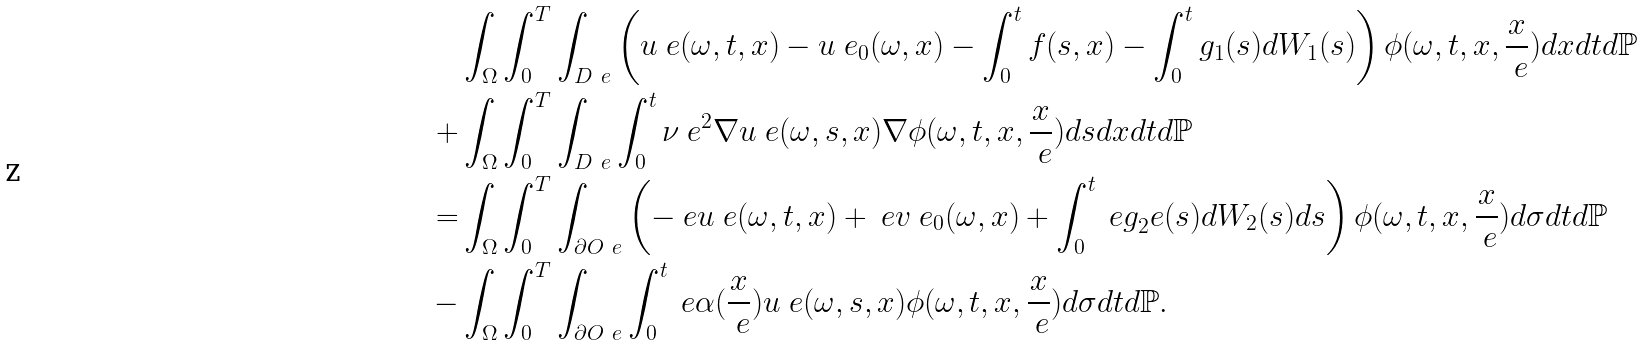Convert formula to latex. <formula><loc_0><loc_0><loc_500><loc_500>& \int _ { \Omega } \int _ { 0 } ^ { T } \int _ { D ^ { \ } e } \left ( u ^ { \ } e ( \omega , t , x ) - u ^ { \ } e _ { 0 } ( \omega , x ) - \int _ { 0 } ^ { t } f ( s , x ) - \int _ { 0 } ^ { t } g _ { 1 } ( s ) d W _ { 1 } ( s ) \right ) \phi ( \omega , t , x , \frac { x } { \ e } ) d x d t d \mathbb { P } \\ + & \int _ { \Omega } \int _ { 0 } ^ { T } \int _ { D ^ { \ } e } \int _ { 0 } ^ { t } \nu \ e ^ { 2 } \nabla u ^ { \ } e ( \omega , s , x ) \nabla \phi ( \omega , t , x , \frac { x } { \ e } ) d s d x d t d \mathbb { P } \\ = & \int _ { \Omega } \int _ { 0 } ^ { T } \int _ { \partial O ^ { \ } e } \left ( - \ e u ^ { \ } e ( \omega , t , x ) + \ e v ^ { \ } e _ { 0 } ( \omega , x ) + \int _ { 0 } ^ { t } \ e g _ { 2 } ^ { \ } e ( s ) d W _ { 2 } ( s ) d s \right ) \phi ( \omega , t , x , \frac { x } { \ e } ) d \sigma d t d \mathbb { P } \\ - & \int _ { \Omega } \int _ { 0 } ^ { T } \int _ { \partial O ^ { \ } e } \int _ { 0 } ^ { t } \ e \alpha ( \frac { x } { \ e } ) u ^ { \ } e ( \omega , s , x ) \phi ( \omega , t , x , \frac { x } { \ e } ) d \sigma d t d \mathbb { P } .</formula> 